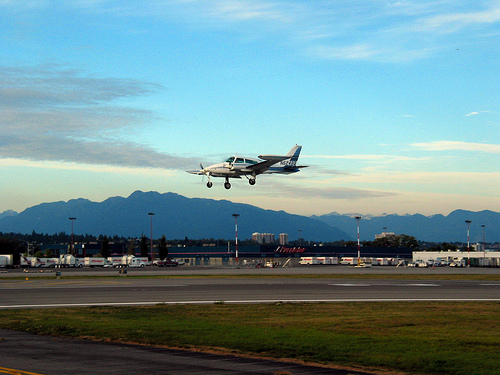<image>
Can you confirm if the airplane is on the tarmac? No. The airplane is not positioned on the tarmac. They may be near each other, but the airplane is not supported by or resting on top of the tarmac. 